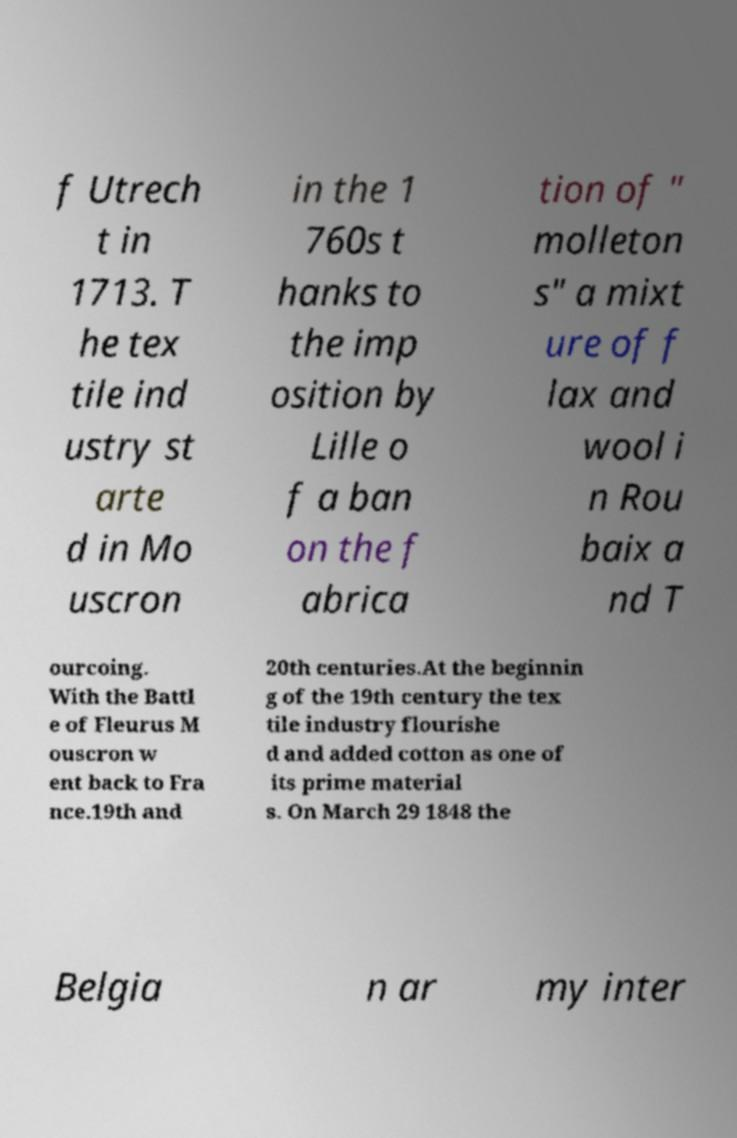What messages or text are displayed in this image? I need them in a readable, typed format. f Utrech t in 1713. T he tex tile ind ustry st arte d in Mo uscron in the 1 760s t hanks to the imp osition by Lille o f a ban on the f abrica tion of " molleton s" a mixt ure of f lax and wool i n Rou baix a nd T ourcoing. With the Battl e of Fleurus M ouscron w ent back to Fra nce.19th and 20th centuries.At the beginnin g of the 19th century the tex tile industry flourishe d and added cotton as one of its prime material s. On March 29 1848 the Belgia n ar my inter 